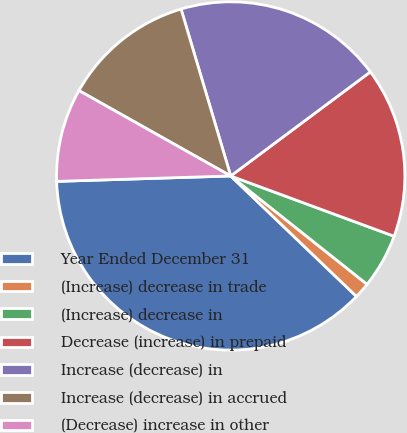Convert chart. <chart><loc_0><loc_0><loc_500><loc_500><pie_chart><fcel>Year Ended December 31<fcel>(Increase) decrease in trade<fcel>(Increase) decrease in<fcel>Decrease (increase) in prepaid<fcel>Increase (decrease) in<fcel>Increase (decrease) in accrued<fcel>(Decrease) increase in other<nl><fcel>37.35%<fcel>1.47%<fcel>5.06%<fcel>15.82%<fcel>19.41%<fcel>12.24%<fcel>8.65%<nl></chart> 